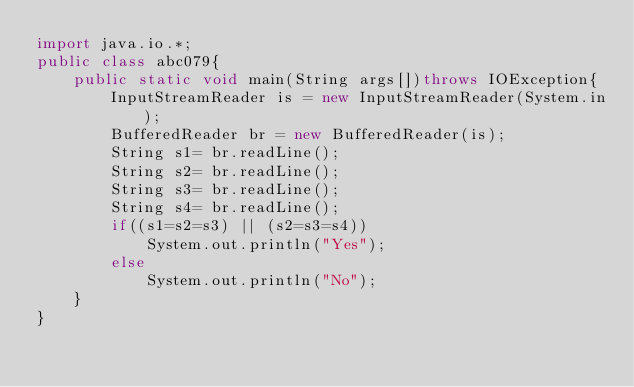<code> <loc_0><loc_0><loc_500><loc_500><_Java_>import java.io.*;
public class abc079{
	public static void main(String args[])throws IOException{
		InputStreamReader is = new InputStreamReader(System.in);
		BufferedReader br = new BufferedReader(is);
		String s1= br.readLine();
		String s2= br.readLine();
		String s3= br.readLine();
		String s4= br.readLine();
		if((s1=s2=s3) || (s2=s3=s4))
			System.out.println("Yes");
		else
			System.out.println("No");
	}
}</code> 